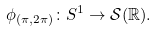<formula> <loc_0><loc_0><loc_500><loc_500>\phi _ { ( \pi , 2 \pi ) } \colon S ^ { 1 } \to \mathcal { S } ( \mathbb { R } ) .</formula> 